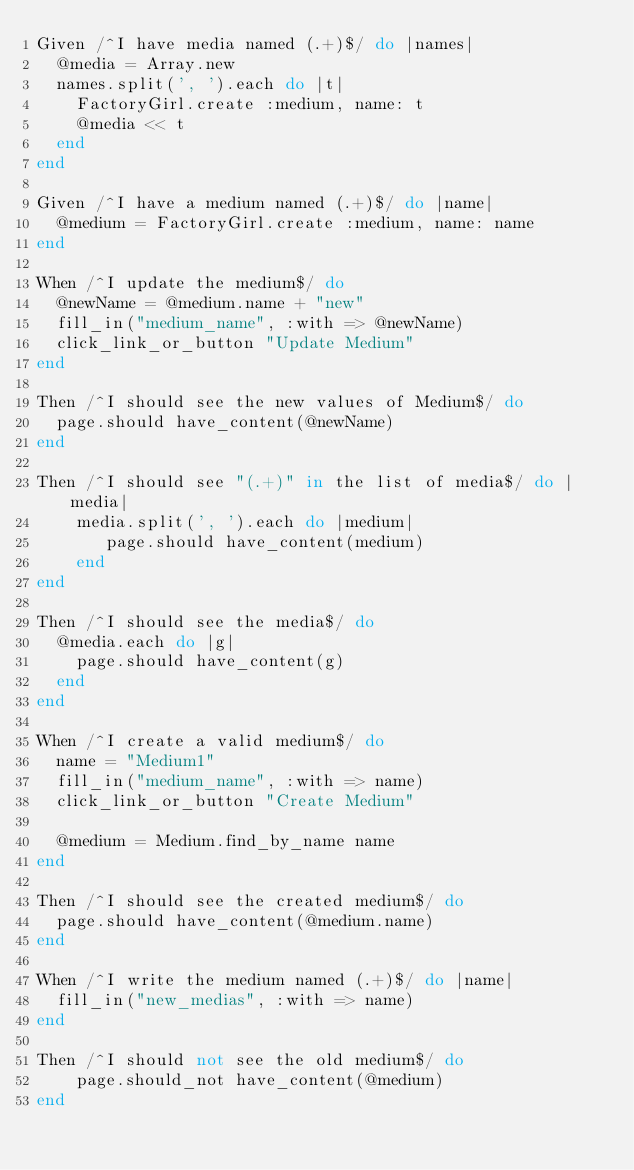Convert code to text. <code><loc_0><loc_0><loc_500><loc_500><_Ruby_>Given /^I have media named (.+)$/ do |names|
  @media = Array.new
  names.split(', ').each do |t|
    FactoryGirl.create :medium, name: t
    @media << t
  end
end

Given /^I have a medium named (.+)$/ do |name|
  @medium = FactoryGirl.create :medium, name: name
end

When /^I update the medium$/ do
  @newName = @medium.name + "new"
  fill_in("medium_name", :with => @newName)
  click_link_or_button "Update Medium"
end

Then /^I should see the new values of Medium$/ do
  page.should have_content(@newName)
end

Then /^I should see "(.+)" in the list of media$/ do |media|
    media.split(', ').each do |medium|
       page.should have_content(medium)
    end
end

Then /^I should see the media$/ do
  @media.each do |g|
    page.should have_content(g)
  end
end

When /^I create a valid medium$/ do
  name = "Medium1"
  fill_in("medium_name", :with => name)
  click_link_or_button "Create Medium"

  @medium = Medium.find_by_name name
end

Then /^I should see the created medium$/ do
  page.should have_content(@medium.name)
end

When /^I write the medium named (.+)$/ do |name|  
  fill_in("new_medias", :with => name)
end

Then /^I should not see the old medium$/ do
    page.should_not have_content(@medium)
end
</code> 